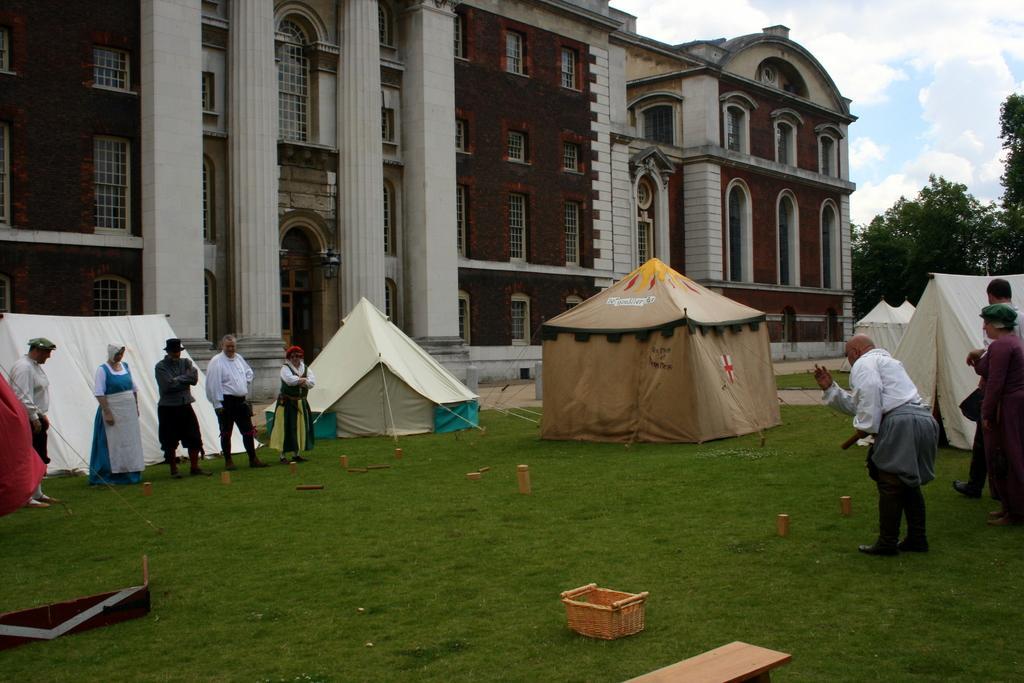How would you summarize this image in a sentence or two? On the ground there is grass. Also there is basket and bench on the ground. And there are few people. There are tents. In the back there is a building with windows, pillars and arches. On the right side there is a sky with clouds and trees. 